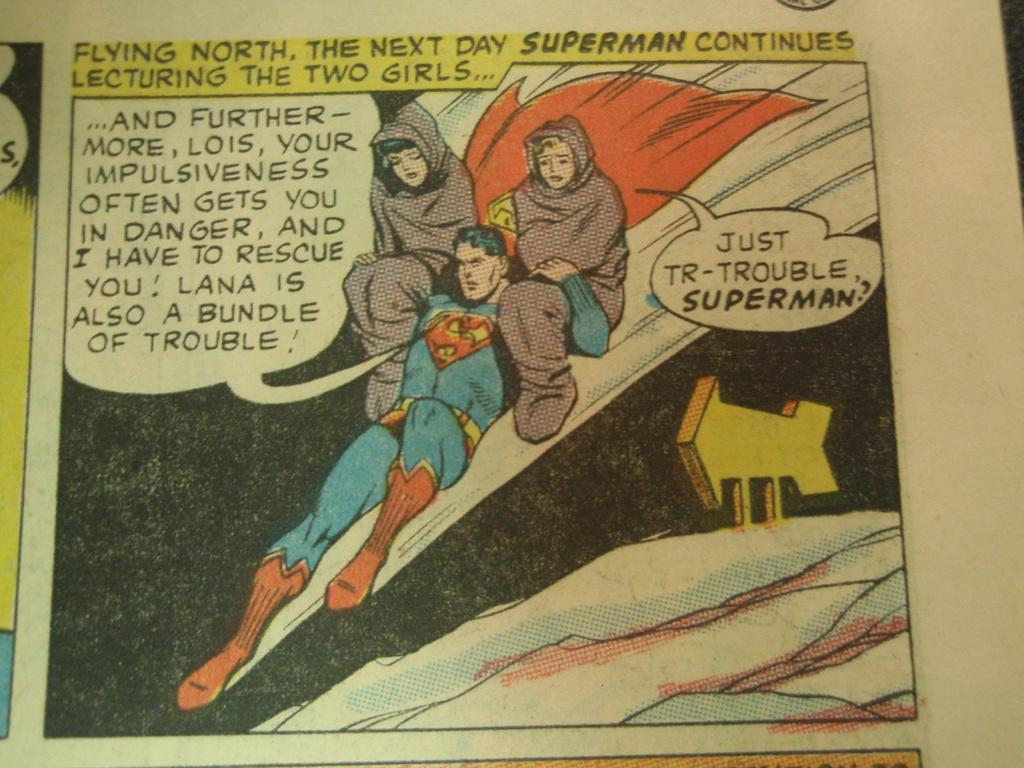<image>
Give a short and clear explanation of the subsequent image. "Flying north, the next day Superman continues lecturing the two girls..." is the header of this comic panel. 